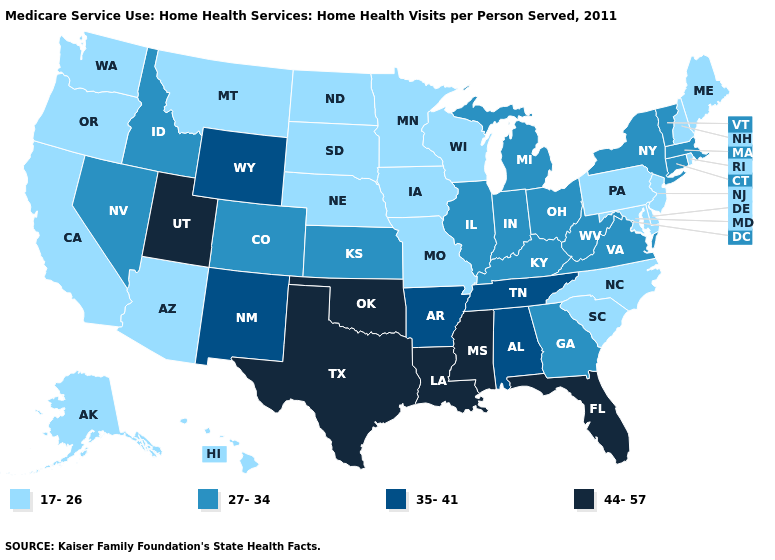Name the states that have a value in the range 44-57?
Be succinct. Florida, Louisiana, Mississippi, Oklahoma, Texas, Utah. Name the states that have a value in the range 35-41?
Write a very short answer. Alabama, Arkansas, New Mexico, Tennessee, Wyoming. Name the states that have a value in the range 17-26?
Write a very short answer. Alaska, Arizona, California, Delaware, Hawaii, Iowa, Maine, Maryland, Minnesota, Missouri, Montana, Nebraska, New Hampshire, New Jersey, North Carolina, North Dakota, Oregon, Pennsylvania, Rhode Island, South Carolina, South Dakota, Washington, Wisconsin. Does Florida have a lower value than Washington?
Concise answer only. No. Does the map have missing data?
Give a very brief answer. No. What is the value of Missouri?
Be succinct. 17-26. Name the states that have a value in the range 35-41?
Quick response, please. Alabama, Arkansas, New Mexico, Tennessee, Wyoming. What is the value of Kansas?
Concise answer only. 27-34. What is the value of Kentucky?
Answer briefly. 27-34. What is the value of Oregon?
Be succinct. 17-26. What is the lowest value in the USA?
Write a very short answer. 17-26. Does Maine have the highest value in the USA?
Quick response, please. No. Name the states that have a value in the range 27-34?
Quick response, please. Colorado, Connecticut, Georgia, Idaho, Illinois, Indiana, Kansas, Kentucky, Massachusetts, Michigan, Nevada, New York, Ohio, Vermont, Virginia, West Virginia. Does the first symbol in the legend represent the smallest category?
Concise answer only. Yes. Does Wisconsin have the highest value in the MidWest?
Concise answer only. No. 